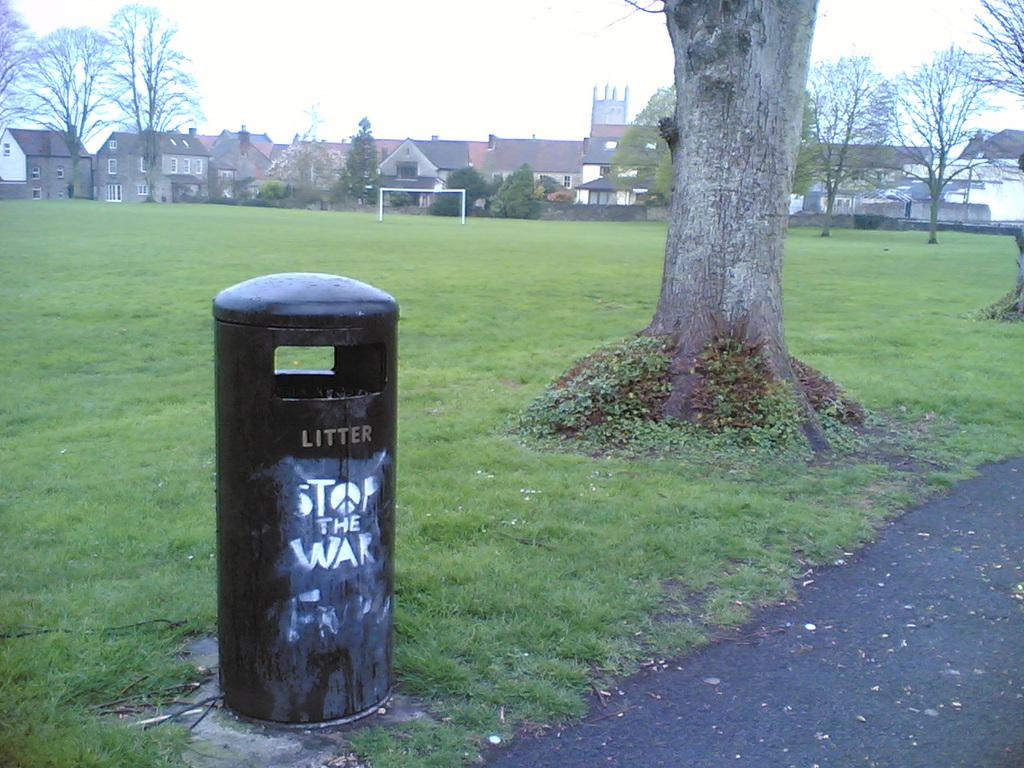Provide a one-sentence caption for the provided image. A public trash can in the park with "Stop the War" drawn on it. 